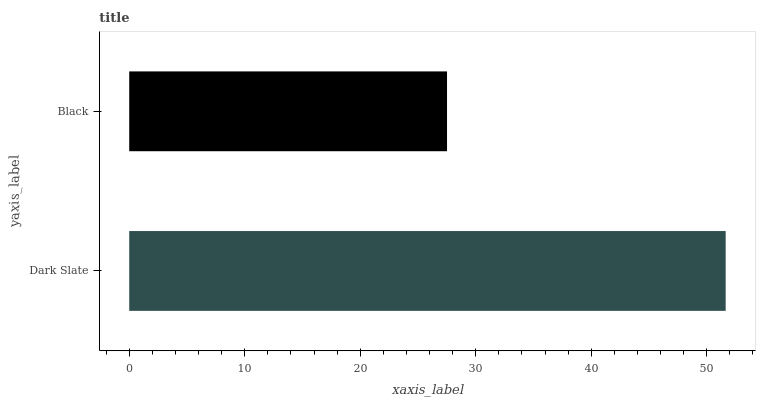Is Black the minimum?
Answer yes or no. Yes. Is Dark Slate the maximum?
Answer yes or no. Yes. Is Black the maximum?
Answer yes or no. No. Is Dark Slate greater than Black?
Answer yes or no. Yes. Is Black less than Dark Slate?
Answer yes or no. Yes. Is Black greater than Dark Slate?
Answer yes or no. No. Is Dark Slate less than Black?
Answer yes or no. No. Is Dark Slate the high median?
Answer yes or no. Yes. Is Black the low median?
Answer yes or no. Yes. Is Black the high median?
Answer yes or no. No. Is Dark Slate the low median?
Answer yes or no. No. 